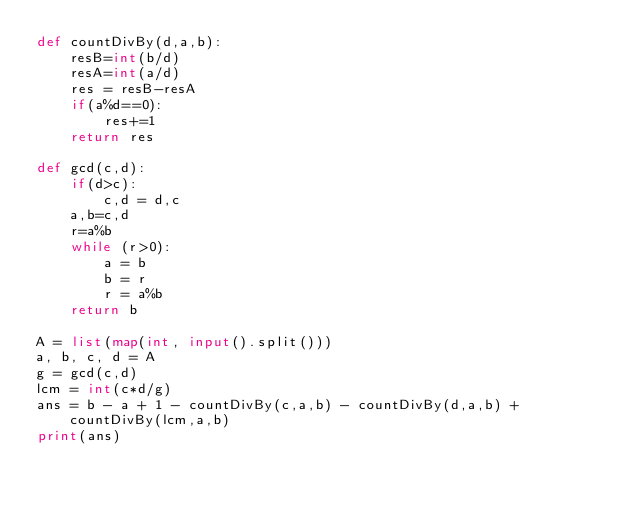<code> <loc_0><loc_0><loc_500><loc_500><_Python_>def countDivBy(d,a,b):
    resB=int(b/d)
    resA=int(a/d)
    res = resB-resA
    if(a%d==0):
        res+=1
    return res
  
def gcd(c,d):
    if(d>c):
        c,d = d,c
    a,b=c,d
    r=a%b
    while (r>0):      
        a = b
        b = r 
        r = a%b
    return b

A = list(map(int, input().split()))
a, b, c, d = A
g = gcd(c,d)
lcm = int(c*d/g)
ans = b - a + 1 - countDivBy(c,a,b) - countDivBy(d,a,b) + countDivBy(lcm,a,b)
print(ans)</code> 